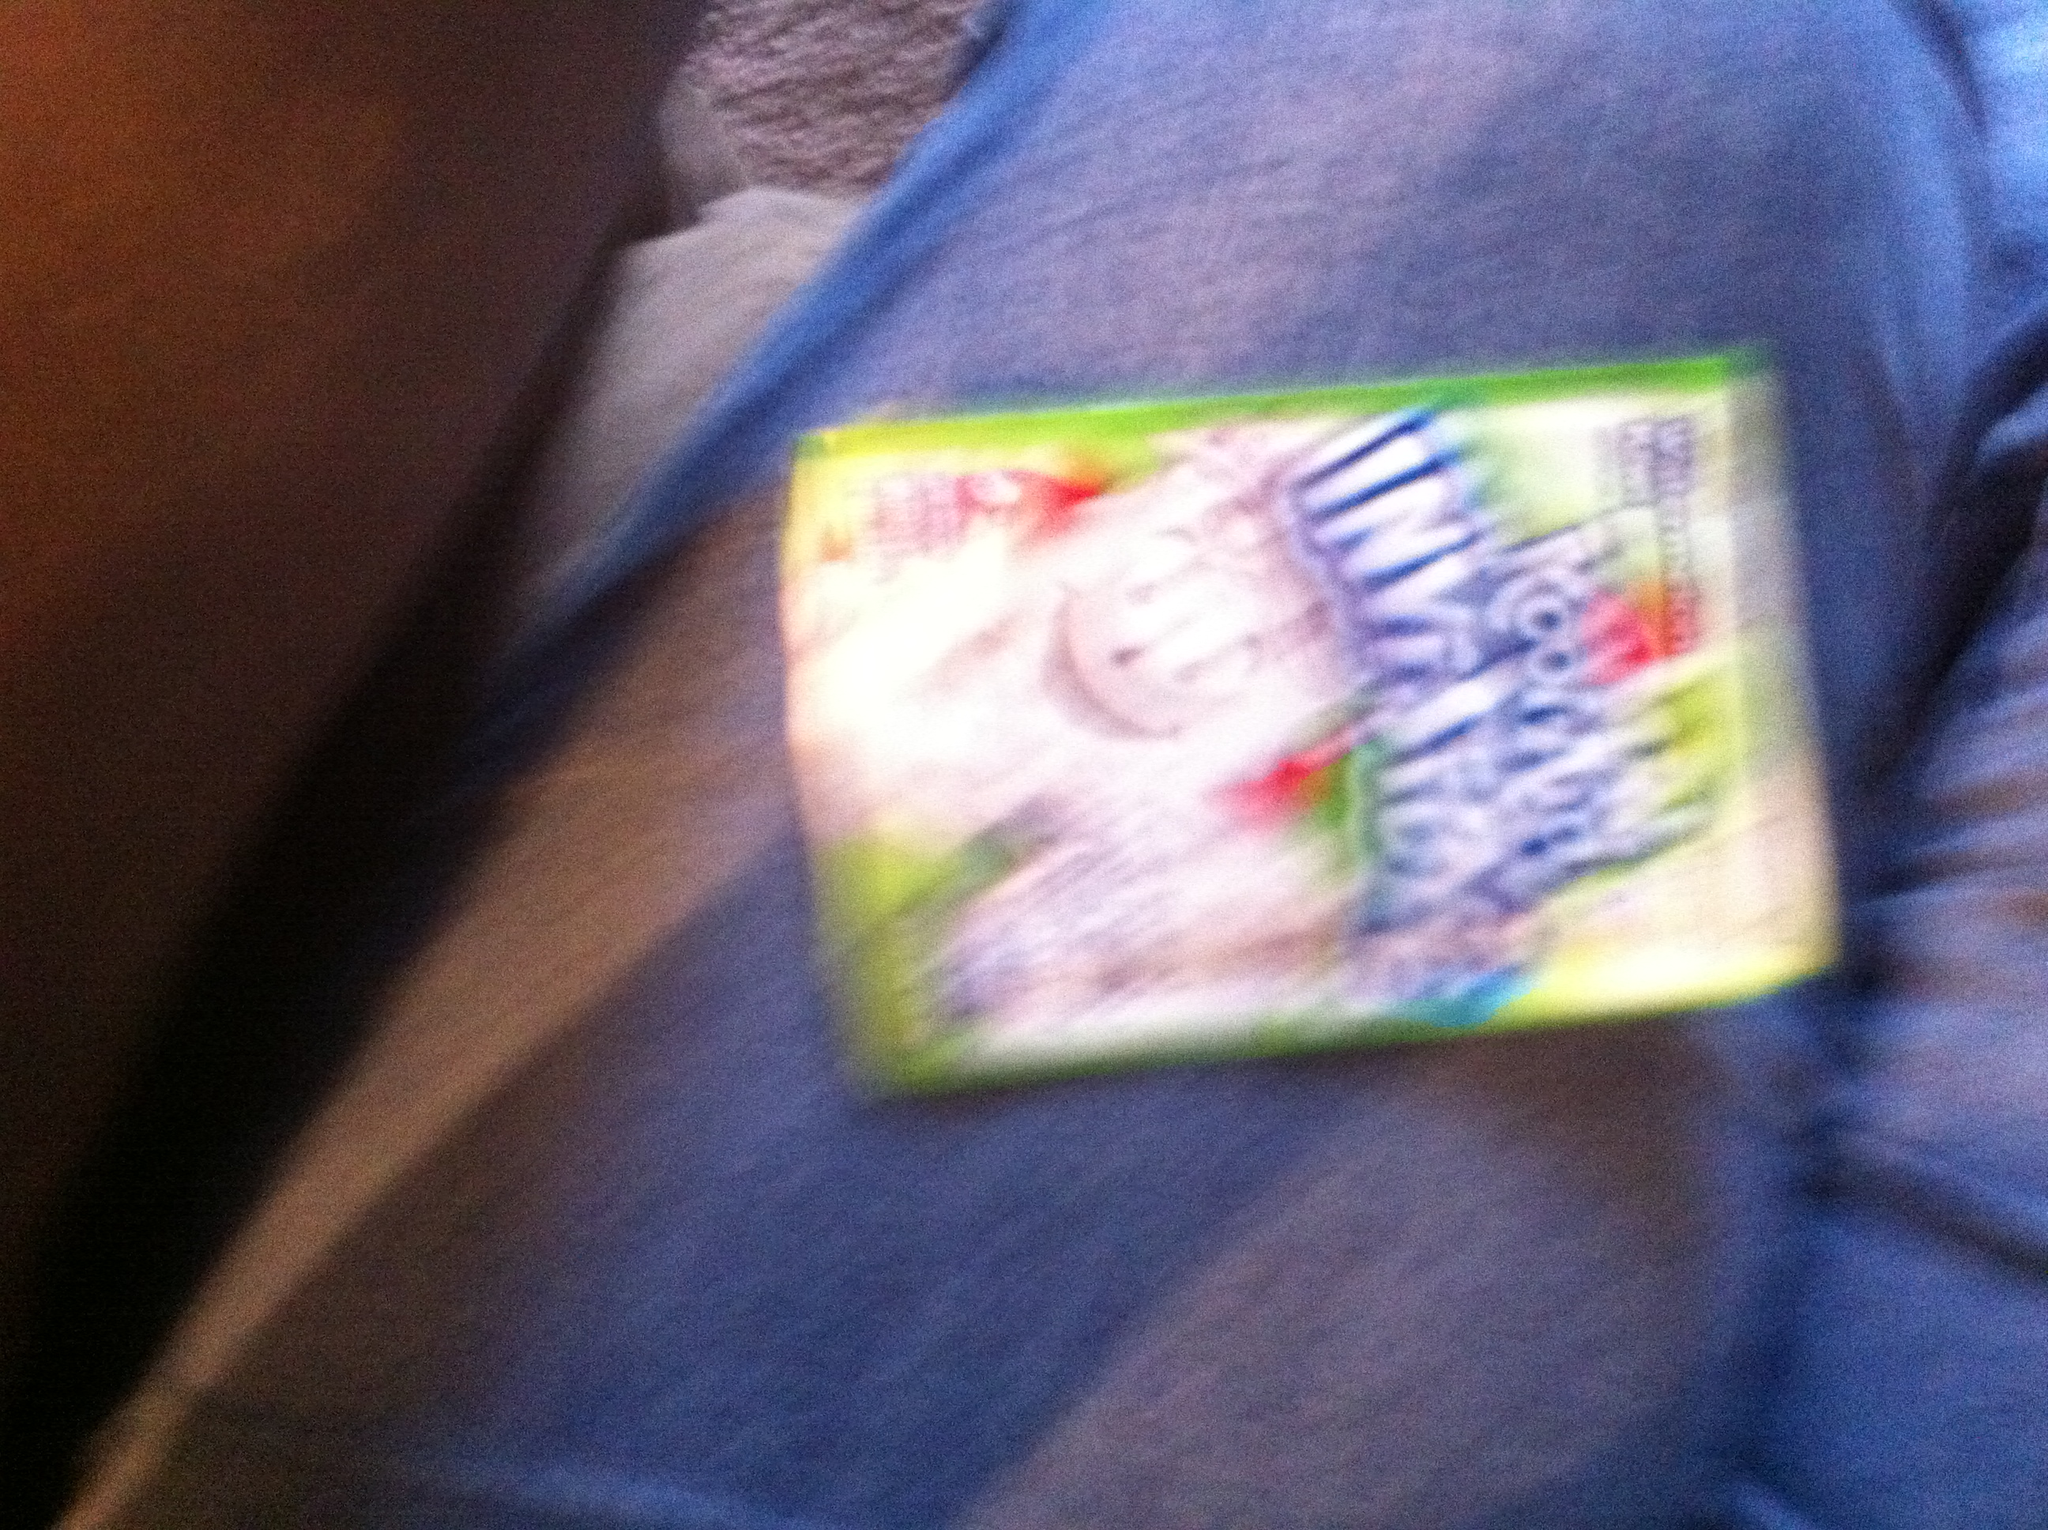I am told that this label of this Kool-Aid is invisible. I do not understand. How does invisible Kool-Aid not have a specific flavor? The term 'invisible' in the context of Kool-Aid or other products often refers to a marketing strategy where the product is clear or colorless, giving the impression that it is 'invisible.' This does not mean the product lacks flavor; rather, it is designed to surprise consumers with the taste despite the absence of color. The concept is to create intrigue and differentiate the product in a unique way. However, without a clear view of the label and further context, determining the specific flavor can be challenging, but it's likely that 'invisible' is not about the absence of flavor but about the visual appearance. 